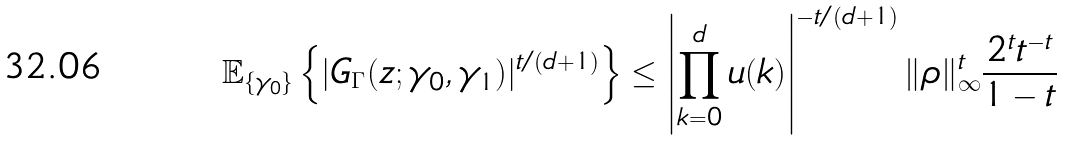<formula> <loc_0><loc_0><loc_500><loc_500>\mathbb { E } _ { \{ \gamma _ { 0 } \} } \left \{ | G _ { \Gamma } ( z ; \gamma _ { 0 } , \gamma _ { 1 } ) | ^ { t / ( d + 1 ) } \right \} \leq \left | \prod _ { k = 0 } ^ { d } u ( k ) \right | ^ { - t / ( d + 1 ) } \| \rho \| _ { \infty } ^ { t } \frac { 2 ^ { t } t ^ { - t } } { 1 - t }</formula> 